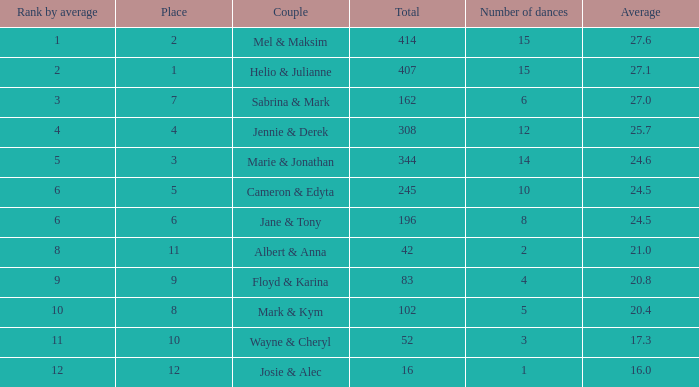What is the smallest place number when the total is 16 and average is less than 16? None. 